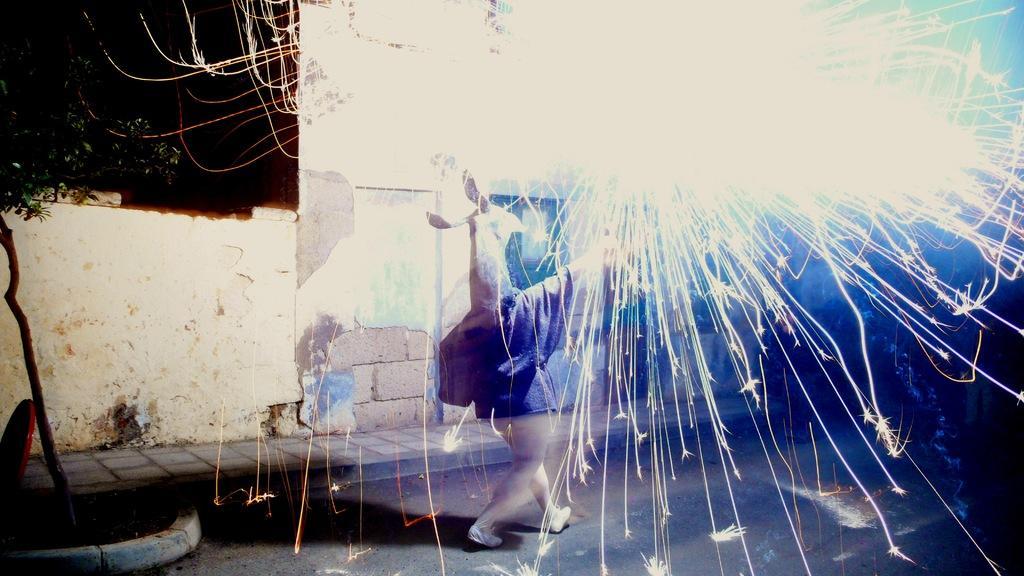Please provide a concise description of this image. In this picture we can see a person on the road, footpath, tree, wall, sparks and some objects and in the background it is dark. 